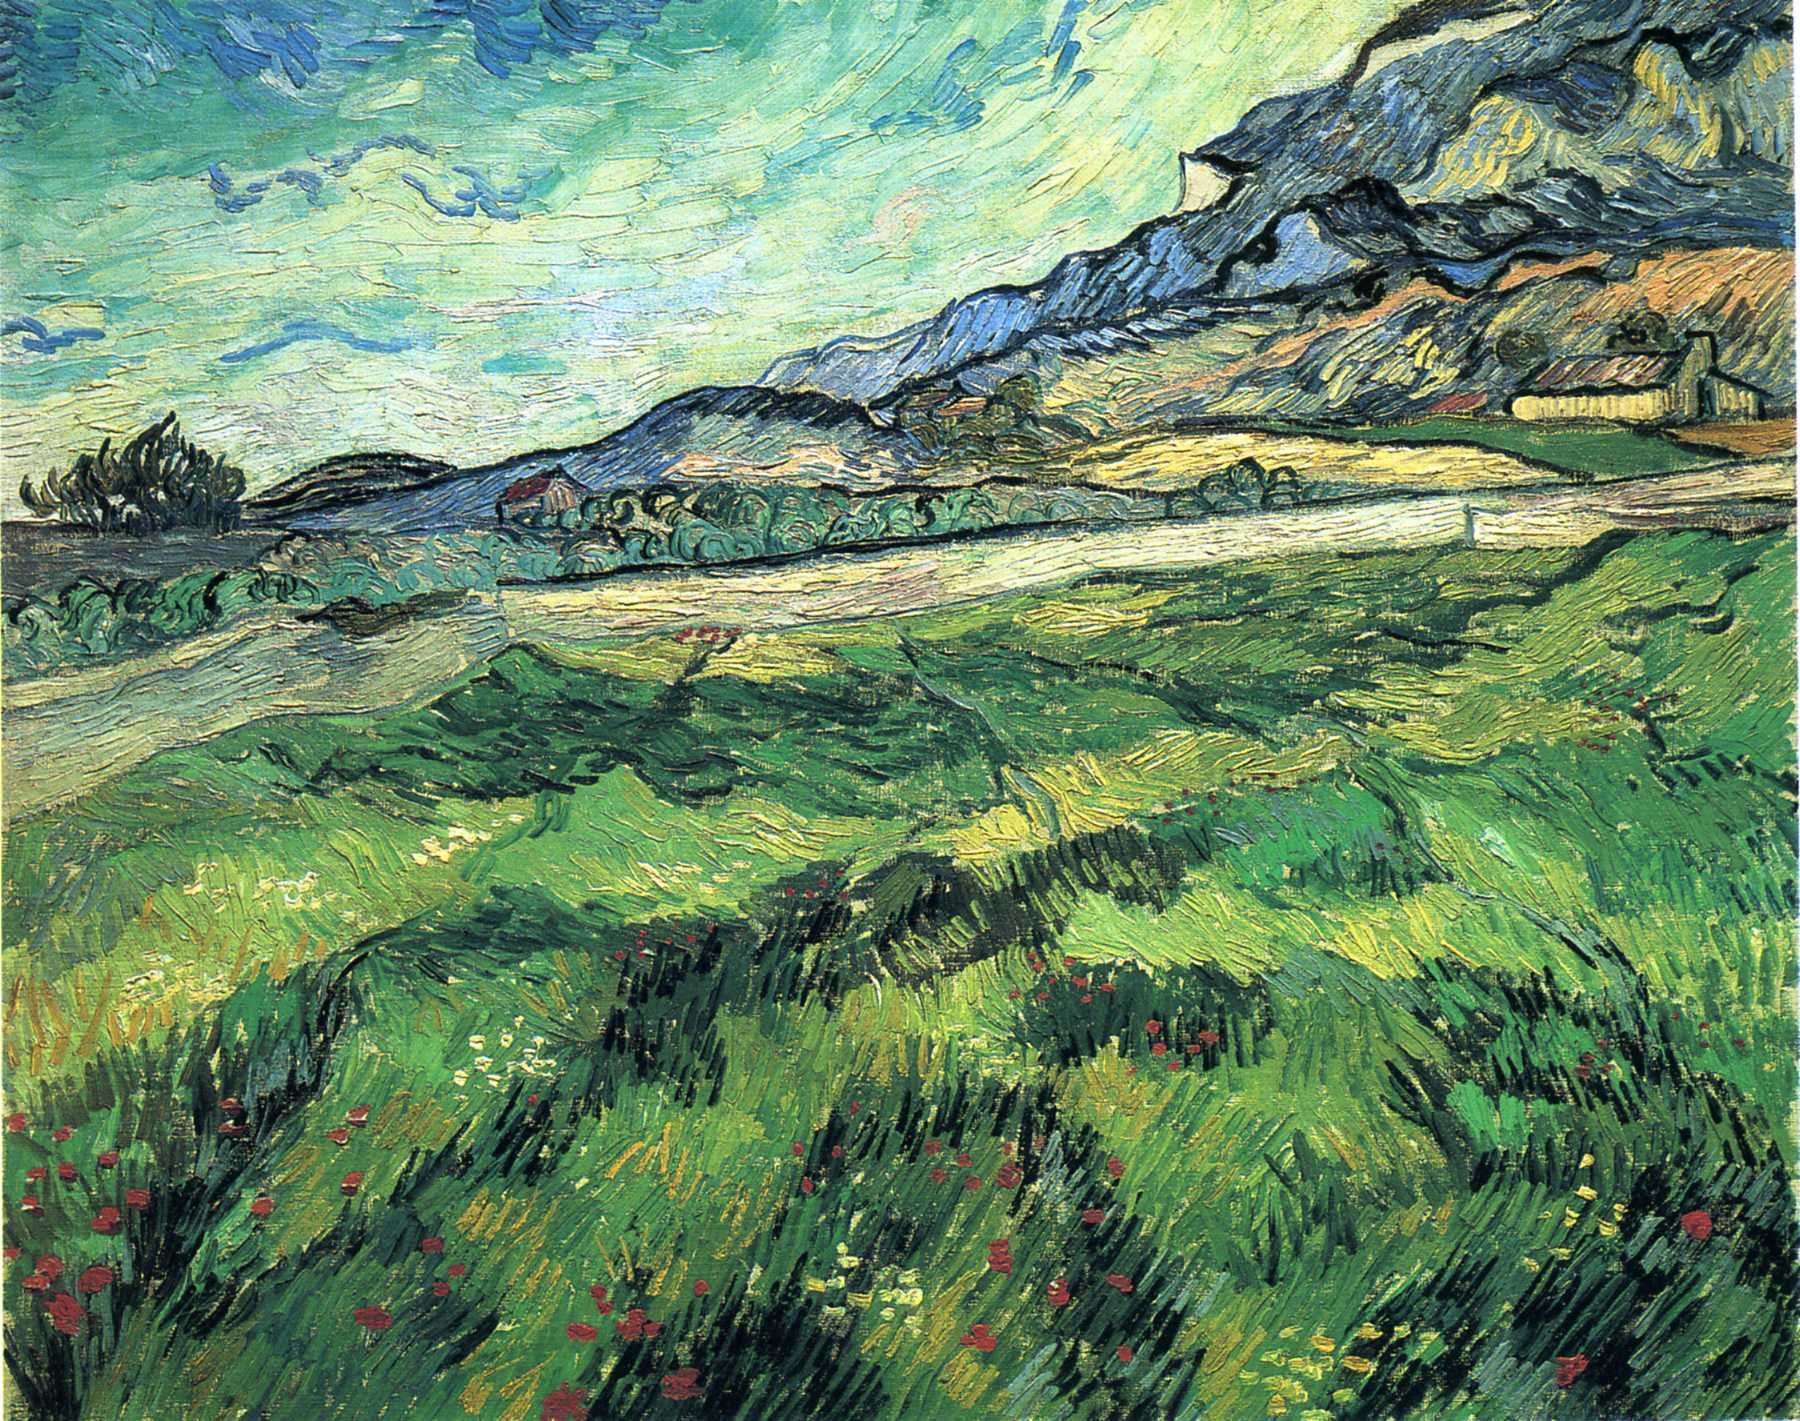Can you tell me a bit more about the artist who created this painting? Vincent Van Gogh, a Dutch post-impressionist painter, is among the most influential figures in the history of Western art. Despite his struggles with mental illness, he created over 2,100 artworks, including around 860 oil paintings, most of which were produced in the last two years of his life. His works are characterized by bold colors, dramatic brushwork, and emotive intensity. Though he lived a life of poverty and obscurity, Van Gogh's work gained widespread critical, commercial, and popular success posthumously. His innovative techniques and heartfelt expressions have left an indelible mark on the art world. What emotions or themes does this painting evoke? This painting evokes a sense of serenity and an almost otherworldly beauty through its dynamic brushstrokes and vibrant color palette. Themes of nature's bounty and the raw power of the landscape are prominent, unified by a sense of emotional intensity that reflects Van Gogh's passionate engagement with his subjects. The swirling sky suggests a turbulent emotional state, adding depth and complexity to what might otherwise be a simple pastoral scene. 